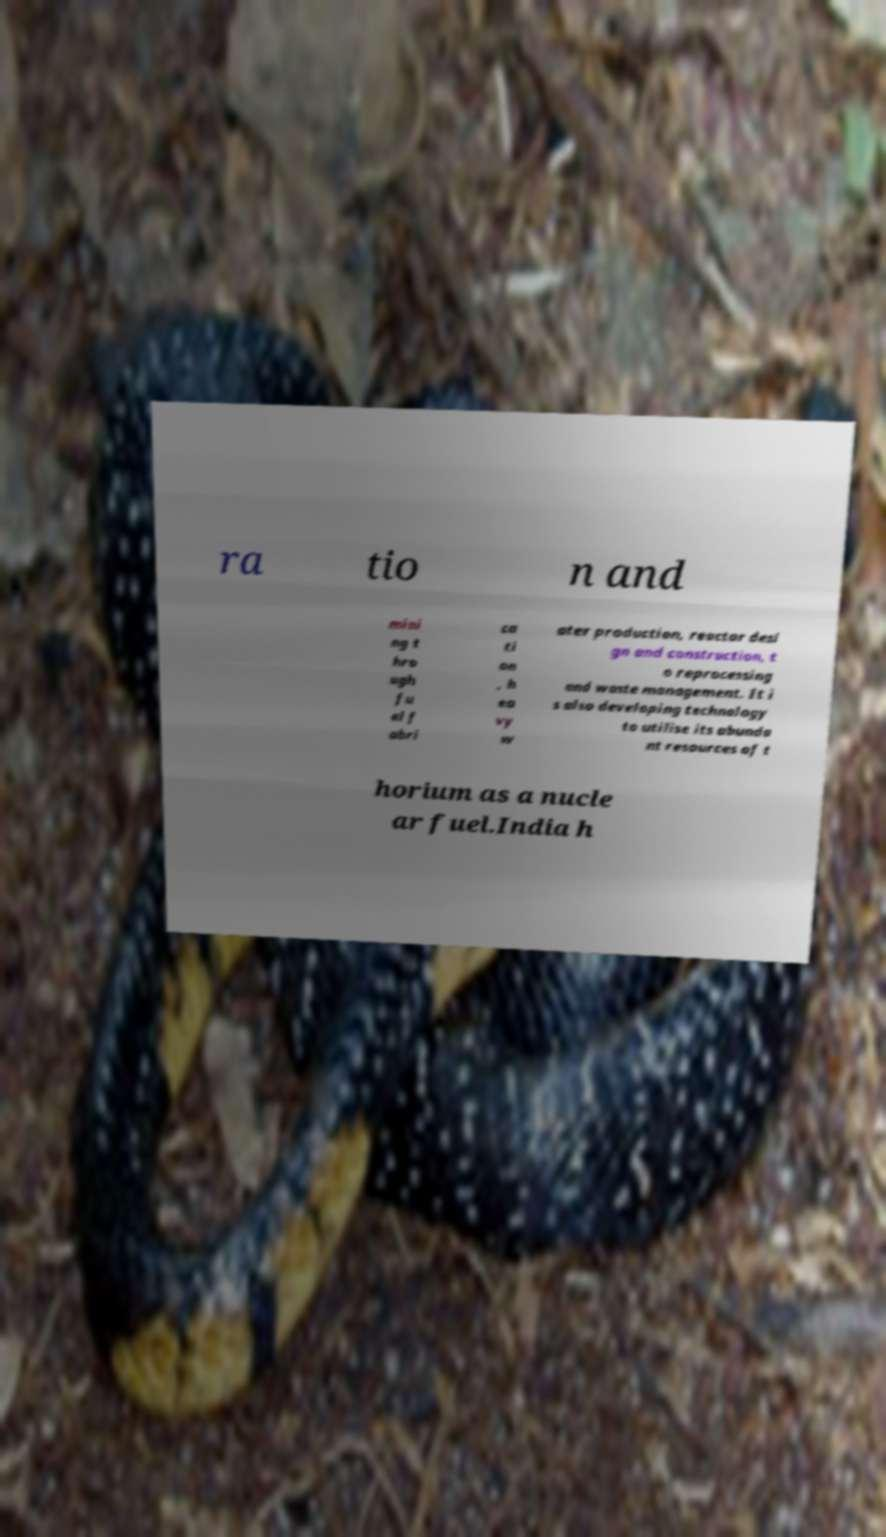I need the written content from this picture converted into text. Can you do that? ra tio n and mini ng t hro ugh fu el f abri ca ti on , h ea vy w ater production, reactor desi gn and construction, t o reprocessing and waste management. It i s also developing technology to utilise its abunda nt resources of t horium as a nucle ar fuel.India h 